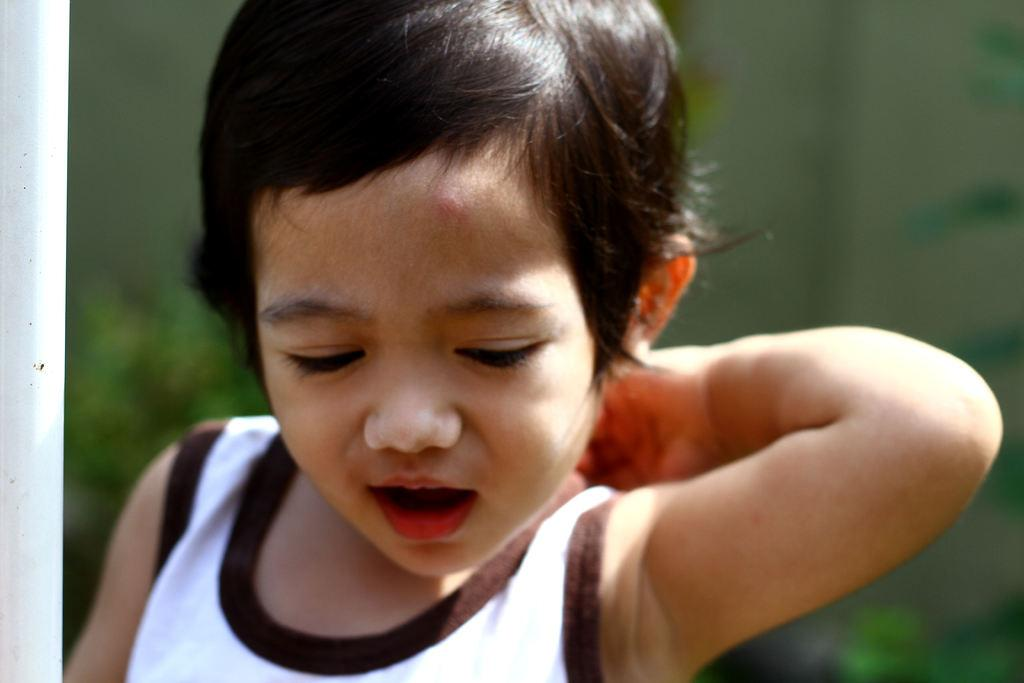What is the main subject of the image? The main subject of the image is a child. What is the weight of the giants in the image? There are no giants present in the image, so their weight cannot be determined. 